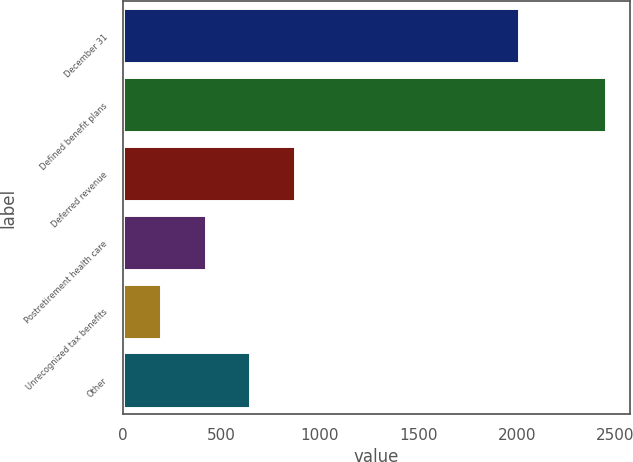<chart> <loc_0><loc_0><loc_500><loc_500><bar_chart><fcel>December 31<fcel>Defined benefit plans<fcel>Deferred revenue<fcel>Postretirement health care<fcel>Unrecognized tax benefits<fcel>Other<nl><fcel>2009<fcel>2450<fcel>872.2<fcel>421.4<fcel>196<fcel>646.8<nl></chart> 